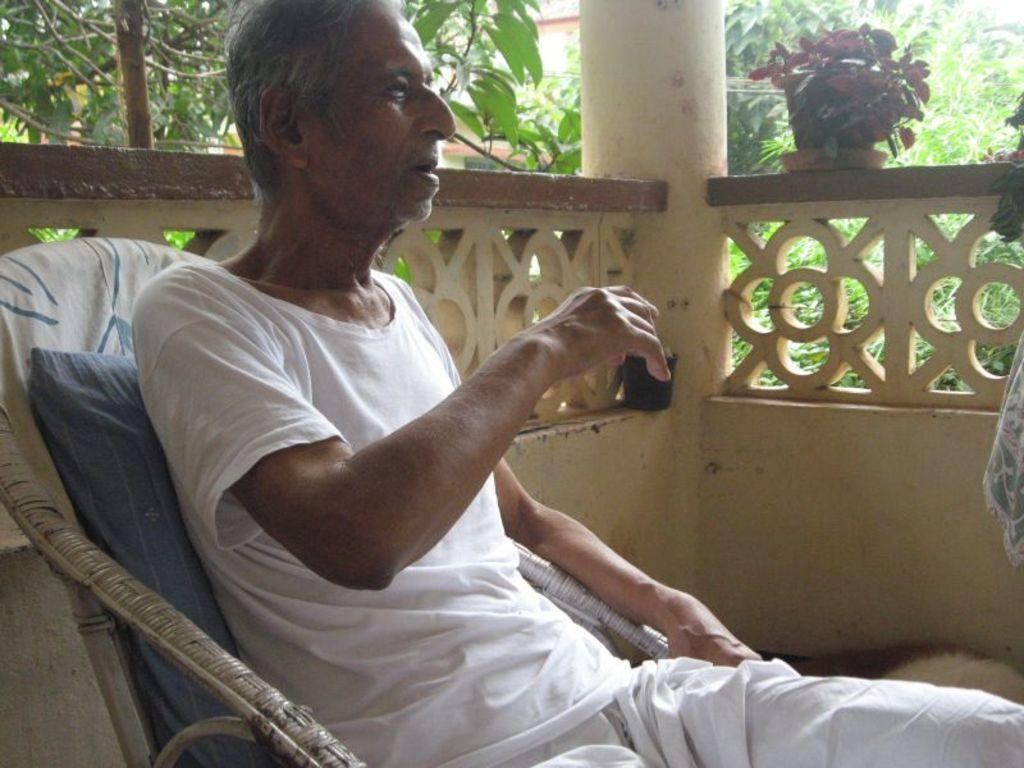What is the main subject of the image? There is a person in the image. What is the person wearing? The person is wearing a dress. What is the person doing in the image? The person is sitting in a chair. What can be seen in the background of the image? There is a fence, a plant in a container, a pillar, and a group of trees in the background of the image. What type of book is the person holding in the image? There is no book present in the image; the person is sitting in a chair wearing a dress. 